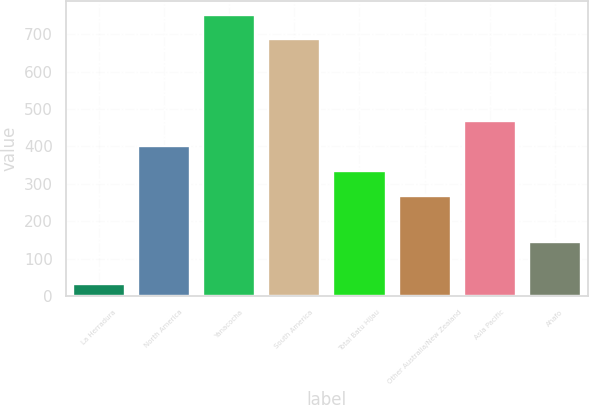Convert chart. <chart><loc_0><loc_0><loc_500><loc_500><bar_chart><fcel>La Herradura<fcel>North America<fcel>Yanacocha<fcel>South America<fcel>Total Batu Hijau<fcel>Other Australia/New Zealand<fcel>Asia Pacific<fcel>Ahafo<nl><fcel>32<fcel>401<fcel>752.2<fcel>686<fcel>334.2<fcel>268<fcel>467.2<fcel>145<nl></chart> 